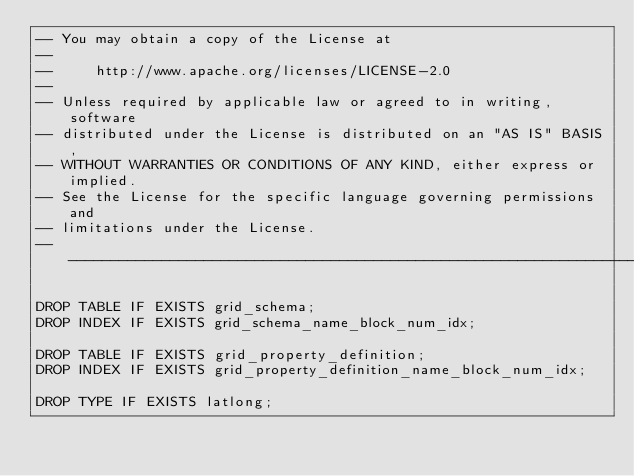<code> <loc_0><loc_0><loc_500><loc_500><_SQL_>-- You may obtain a copy of the License at
--
--     http://www.apache.org/licenses/LICENSE-2.0
--
-- Unless required by applicable law or agreed to in writing, software
-- distributed under the License is distributed on an "AS IS" BASIS,
-- WITHOUT WARRANTIES OR CONDITIONS OF ANY KIND, either express or implied.
-- See the License for the specific language governing permissions and
-- limitations under the License.
-- -----------------------------------------------------------------------------

DROP TABLE IF EXISTS grid_schema;
DROP INDEX IF EXISTS grid_schema_name_block_num_idx;

DROP TABLE IF EXISTS grid_property_definition;
DROP INDEX IF EXISTS grid_property_definition_name_block_num_idx;

DROP TYPE IF EXISTS latlong;
</code> 